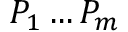<formula> <loc_0><loc_0><loc_500><loc_500>P _ { 1 } \dots P _ { m }</formula> 